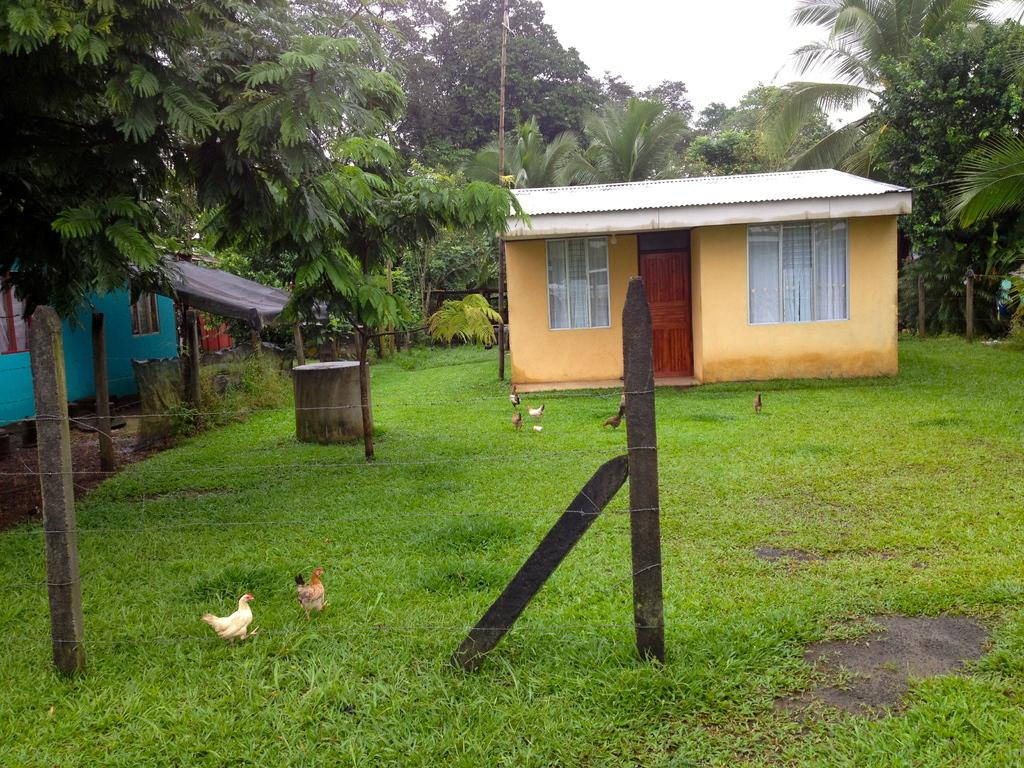What type of barrier can be seen in the image? There is a fence in the image. What is on the grass in the image? There are flocks of birds on the grass. What can be seen in the background of the image? There are houses, trees, windows, and the sky visible in the background. Can you describe the time of day when the image was taken? The image is likely taken during the day, as the sky is visible and there is sufficient light. What type of desk can be seen in the image? There is no desk present in the image. How does the grip of the fork in the image affect the birds? There is no fork present in the image, so the grip cannot affect the birds. 